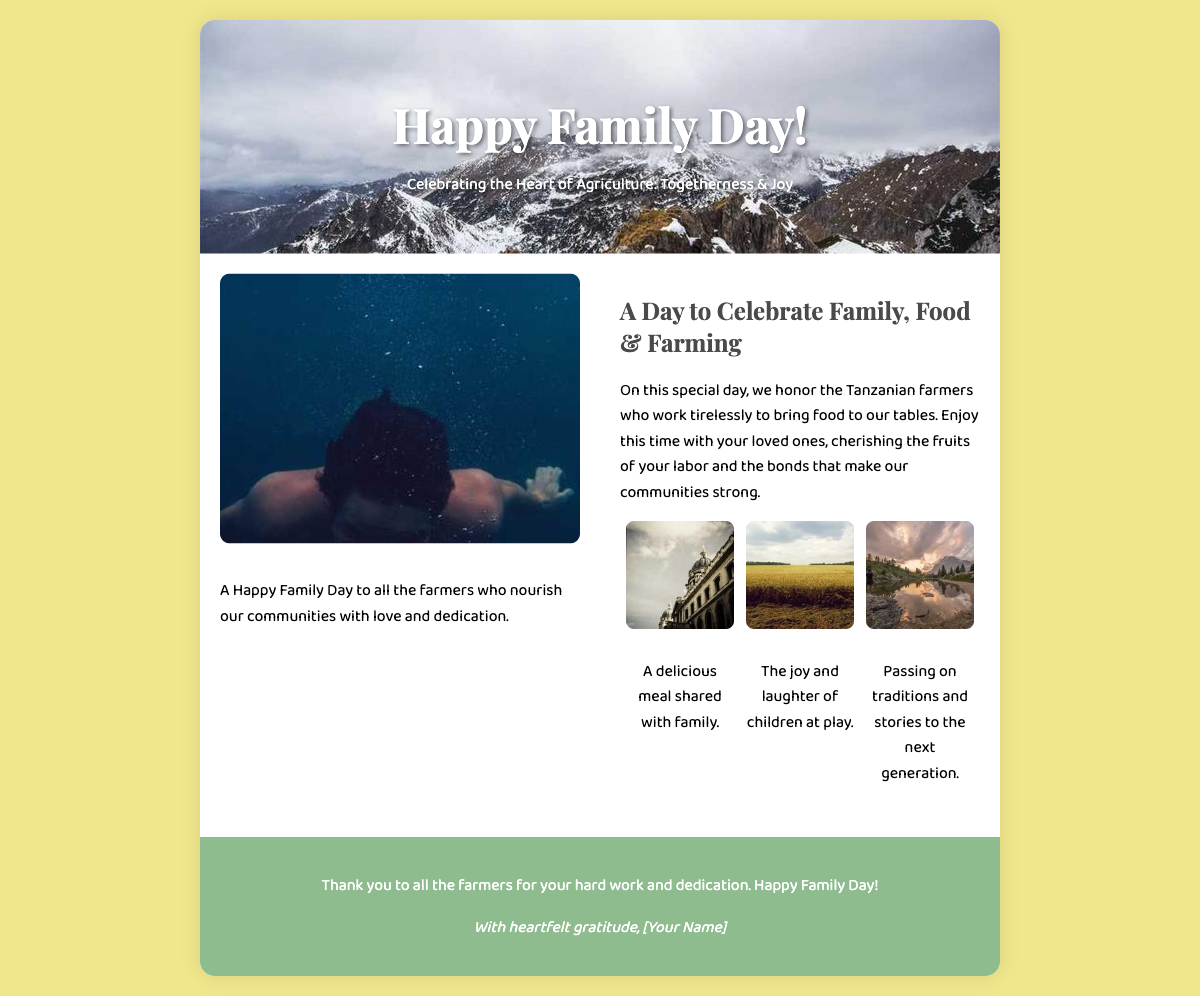What is the title of the card? The title is prominently displayed at the top of the front cover, which is "Happy Family Day!"
Answer: Happy Family Day! What is the theme of the celebration? The theme is stated in the subtitle of the front cover, which is about togetherness and joy in agriculture.
Answer: Togetherness & Joy Who does the card honor? The inside right section explicitly mentions who the card honors, which is Tanzanian farmers.
Answer: Tanzanian farmers What is one of the activities depicted in the elements section? In the elements section, there is an image showing children engaged in a specific activity.
Answer: Playing What does the card thank farmers for? The back cover summarizes the gratitude expressed toward farmers for their hard work and dedication.
Answer: Hard work and dedication What is illustrated in the left inside section? The left inside section contains a visual element, characterized by an image and a related message.
Answer: Tanzanian farmers family What meal-related depiction is featured in the card? The card includes a meal depicted in the elements section, highlighting a specific type of gathering.
Answer: Family meal How many key elements are highlighted in the inside right section? The inside right section features a collection of key elements with a specific number mentioned.
Answer: Three Who is suggested to give the card? The back cover includes a sign-off that signifies who might be sending this card.
Answer: [Your Name] 